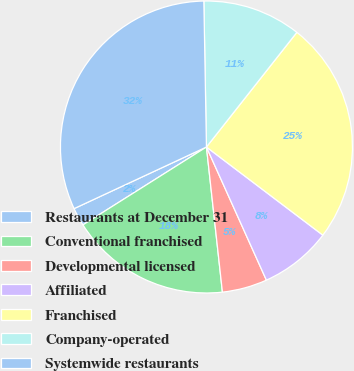Convert chart to OTSL. <chart><loc_0><loc_0><loc_500><loc_500><pie_chart><fcel>Restaurants at December 31<fcel>Conventional franchised<fcel>Developmental licensed<fcel>Affiliated<fcel>Franchised<fcel>Company-operated<fcel>Systemwide restaurants<nl><fcel>2.02%<fcel>17.79%<fcel>4.99%<fcel>7.95%<fcel>24.69%<fcel>10.91%<fcel>31.65%<nl></chart> 